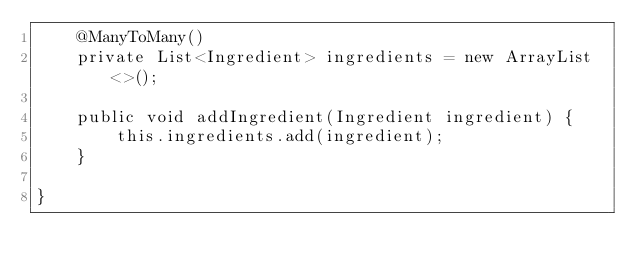Convert code to text. <code><loc_0><loc_0><loc_500><loc_500><_Java_>    @ManyToMany()
    private List<Ingredient> ingredients = new ArrayList<>();

    public void addIngredient(Ingredient ingredient) {
        this.ingredients.add(ingredient);
    }

}</code> 